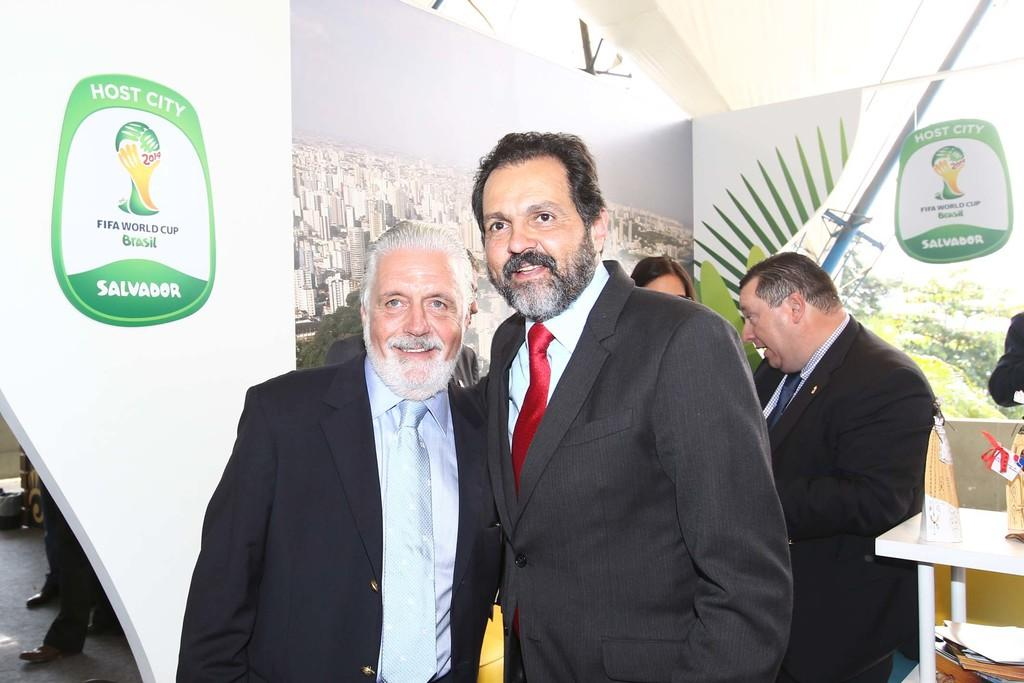What is happening in the image? There are people standing in the image. Can you describe the expressions of the people? Some people have smiles on their faces. What can be seen in the background of the image? There is a poster of FIFA World Cup in the background of the image. How many snails can be seen crawling on the poster in the image? There are no snails present in the image, and therefore none can be seen crawling on the poster. 